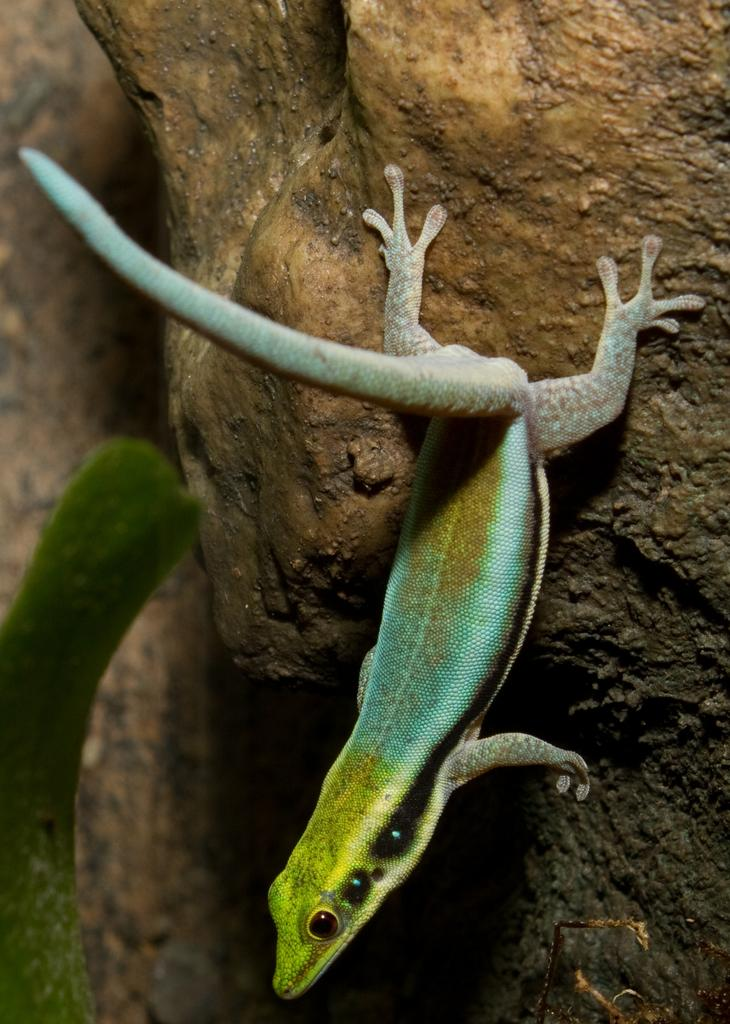What type of animal is in the image? There is a lizard in the image. Where is the lizard located? The lizard is on a rock. What note is the lizard playing on the rock in the image? There is no musical instrument or note present in the image; it features a lizard on a rock. 